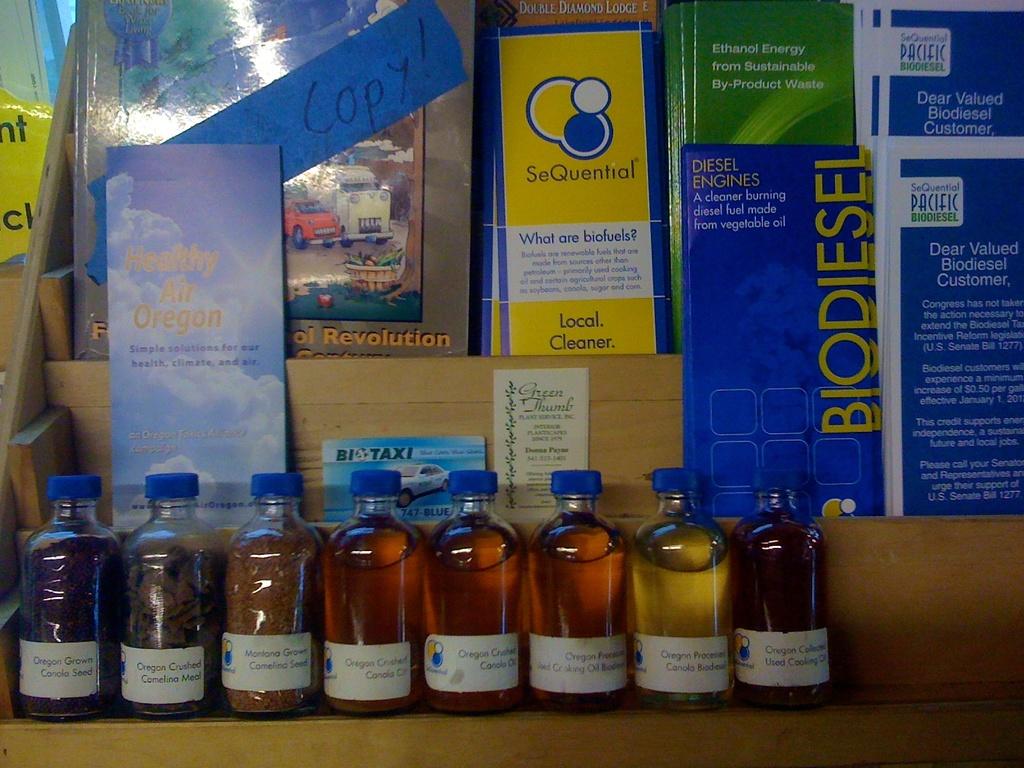What state is mentioned with healthy air?
Ensure brevity in your answer.  Oregon. What state do you see?
Keep it short and to the point. Oregon. 